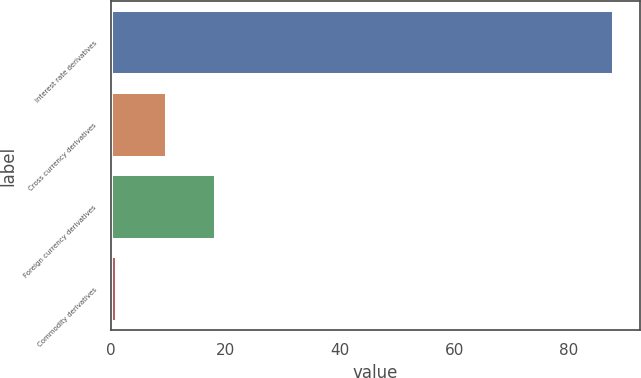Convert chart to OTSL. <chart><loc_0><loc_0><loc_500><loc_500><bar_chart><fcel>Interest rate derivatives<fcel>Cross currency derivatives<fcel>Foreign currency derivatives<fcel>Commodity derivatives<nl><fcel>88<fcel>9.7<fcel>18.4<fcel>1<nl></chart> 